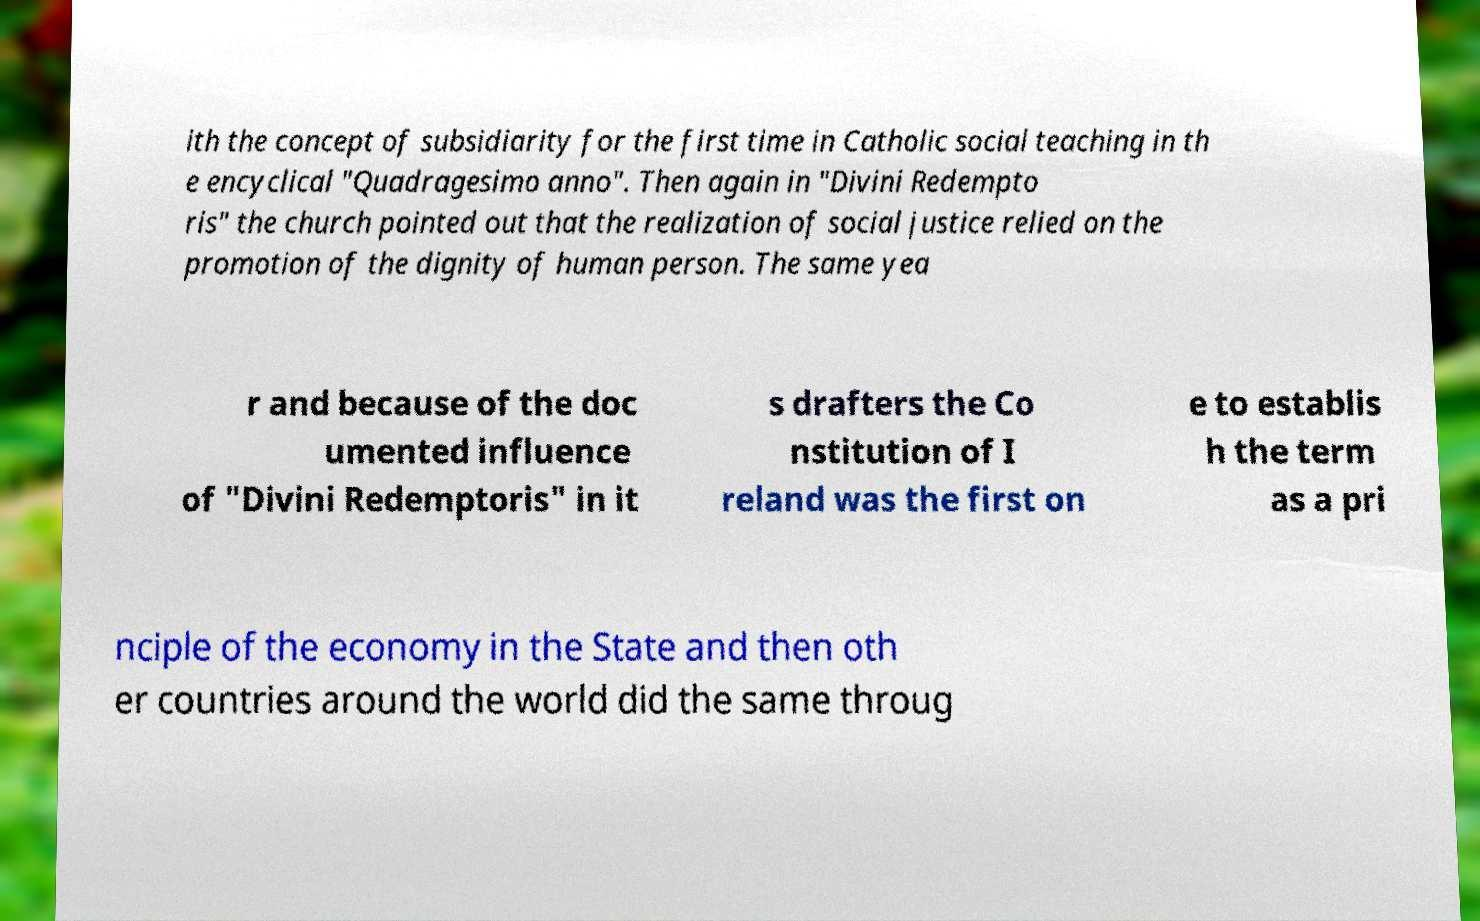Please identify and transcribe the text found in this image. ith the concept of subsidiarity for the first time in Catholic social teaching in th e encyclical "Quadragesimo anno". Then again in "Divini Redempto ris" the church pointed out that the realization of social justice relied on the promotion of the dignity of human person. The same yea r and because of the doc umented influence of "Divini Redemptoris" in it s drafters the Co nstitution of I reland was the first on e to establis h the term as a pri nciple of the economy in the State and then oth er countries around the world did the same throug 